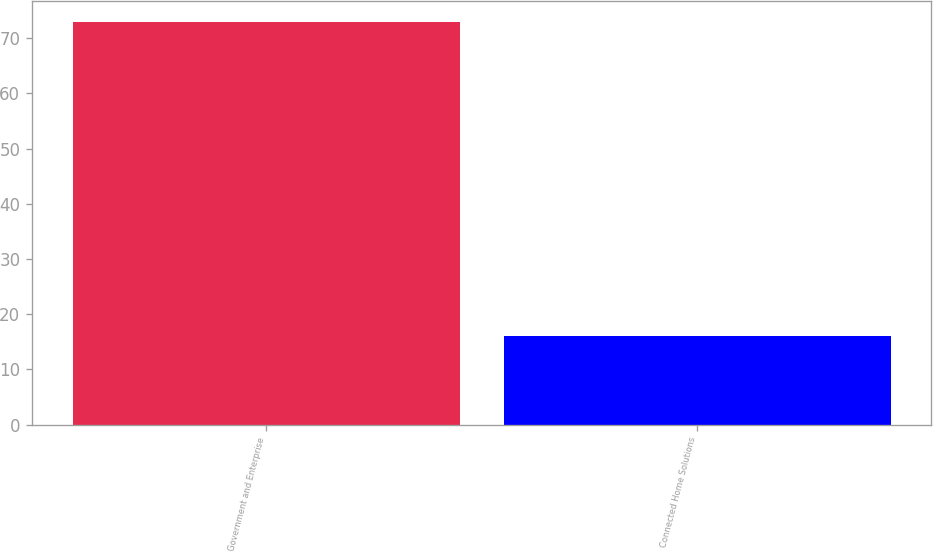<chart> <loc_0><loc_0><loc_500><loc_500><bar_chart><fcel>Government and Enterprise<fcel>Connected Home Solutions<nl><fcel>73<fcel>16<nl></chart> 